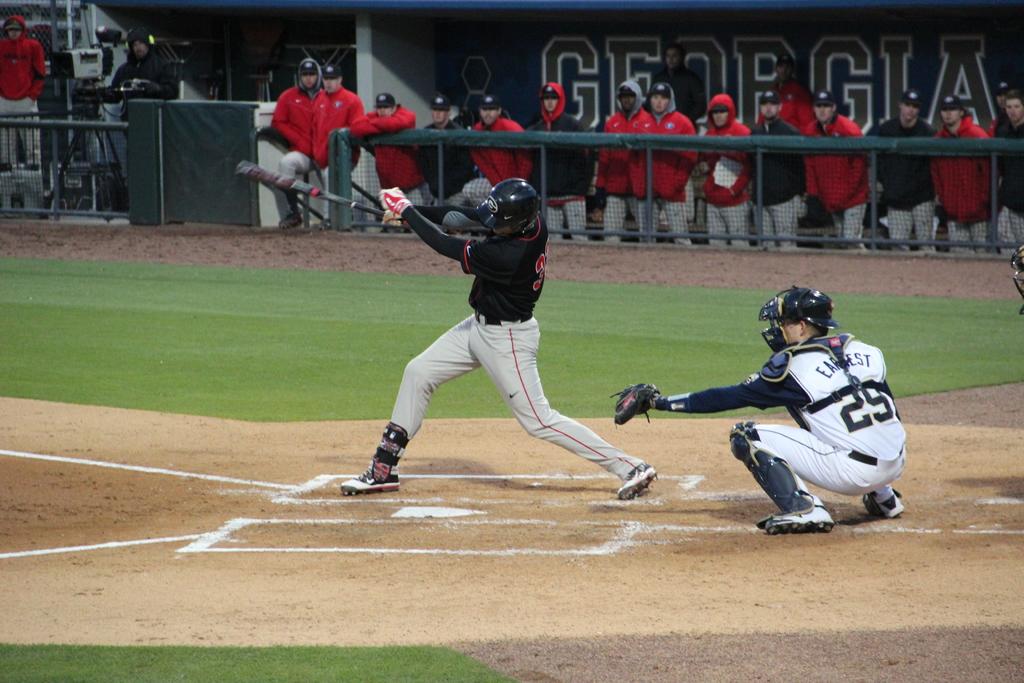What is the catcher's number?
Give a very brief answer. 29. What state is the team?
Give a very brief answer. Georgia. 